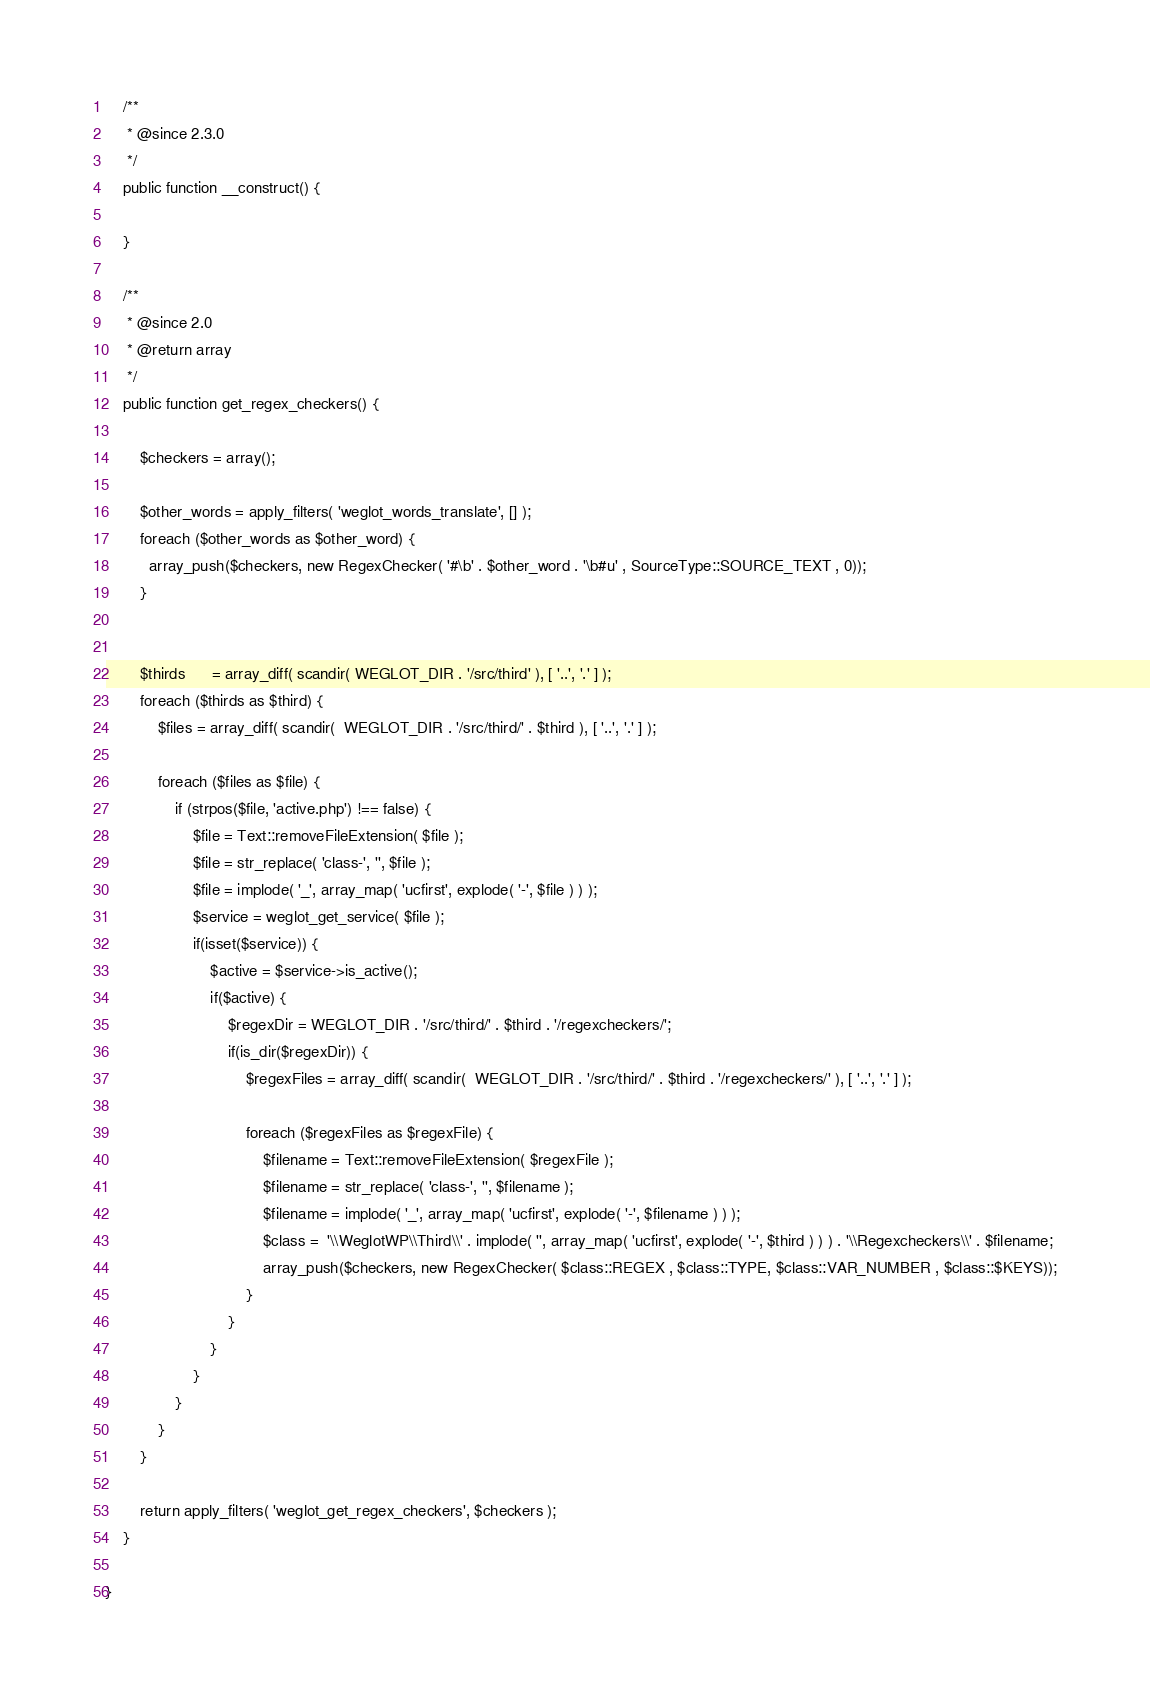Convert code to text. <code><loc_0><loc_0><loc_500><loc_500><_PHP_>    /**
     * @since 2.3.0
     */
    public function __construct() {

    }

	/**
	 * @since 2.0
	 * @return array
	 */
	public function get_regex_checkers() {

        $checkers = array();

        $other_words = apply_filters( 'weglot_words_translate', [] );
        foreach ($other_words as $other_word) {
          array_push($checkers, new RegexChecker( '#\b' . $other_word . '\b#u' , SourceType::SOURCE_TEXT , 0));
        }


        $thirds      = array_diff( scandir( WEGLOT_DIR . '/src/third' ), [ '..', '.' ] );
        foreach ($thirds as $third) {
            $files = array_diff( scandir(  WEGLOT_DIR . '/src/third/' . $third ), [ '..', '.' ] );

            foreach ($files as $file) {
                if (strpos($file, 'active.php') !== false) {
                    $file = Text::removeFileExtension( $file );
                    $file = str_replace( 'class-', '', $file );
                    $file = implode( '_', array_map( 'ucfirst', explode( '-', $file ) ) );
                    $service = weglot_get_service( $file );
                    if(isset($service)) {
                        $active = $service->is_active();
                        if($active) {
                            $regexDir = WEGLOT_DIR . '/src/third/' . $third . '/regexcheckers/';
                            if(is_dir($regexDir)) {
                                $regexFiles = array_diff( scandir(  WEGLOT_DIR . '/src/third/' . $third . '/regexcheckers/' ), [ '..', '.' ] );

                                foreach ($regexFiles as $regexFile) {
                                    $filename = Text::removeFileExtension( $regexFile );
                                    $filename = str_replace( 'class-', '', $filename );
                                    $filename = implode( '_', array_map( 'ucfirst', explode( '-', $filename ) ) );
                                    $class =  '\\WeglotWP\\Third\\' . implode( '', array_map( 'ucfirst', explode( '-', $third ) ) ) . '\\Regexcheckers\\' . $filename;
                                    array_push($checkers, new RegexChecker( $class::REGEX , $class::TYPE, $class::VAR_NUMBER , $class::$KEYS));
                                }
                            }
                        }
                    }
                }
            }
        }

		return apply_filters( 'weglot_get_regex_checkers', $checkers );
	}

}
</code> 